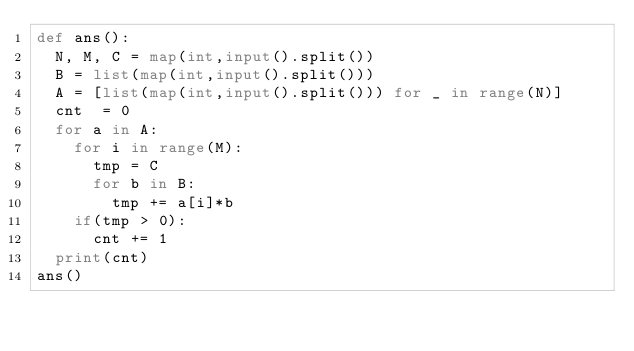Convert code to text. <code><loc_0><loc_0><loc_500><loc_500><_Python_>def ans():
  N, M, C = map(int,input().split())
  B = list(map(int,input().split()))
  A = [list(map(int,input().split())) for _ in range(N)]
  cnt  = 0
  for a in A:
    for i in range(M):
      tmp = C
      for b in B:
        tmp += a[i]*b
    if(tmp > 0):
      cnt += 1
  print(cnt)
ans()</code> 